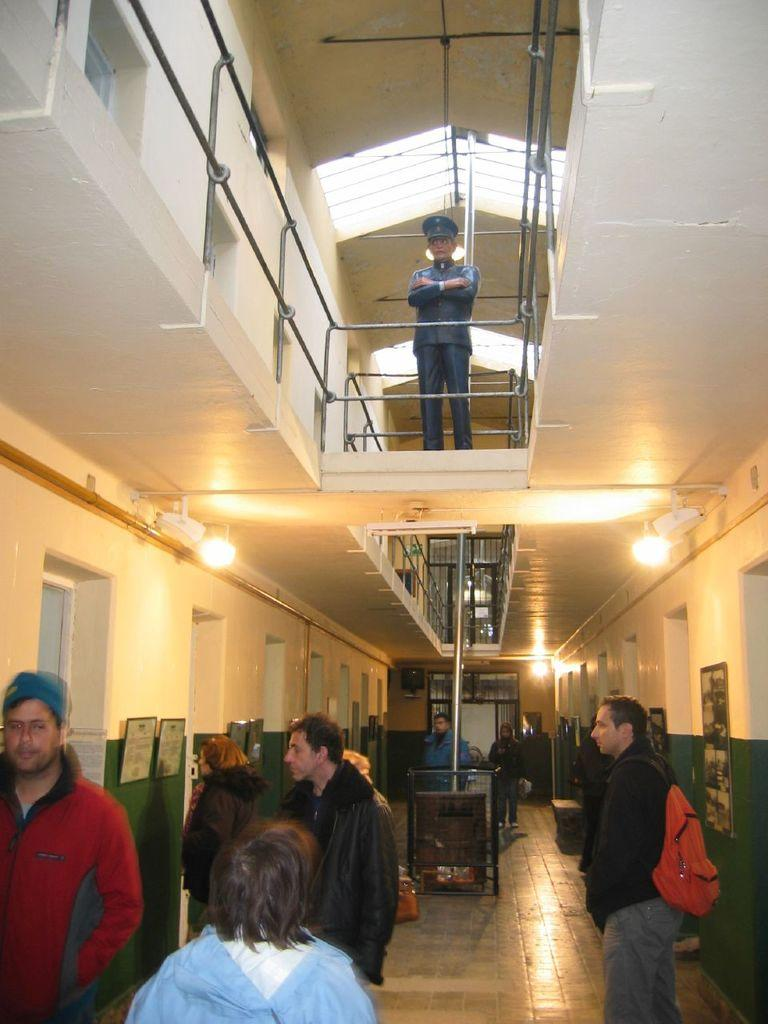What type of structure can be seen in the image? There is a wall in the image. What decorative items are present on the wall? There are photo frames in the image. What type of illumination is visible in the image? There are lights in the image. Are there any people in the image? Yes, there are people present in the image. What type of trousers can be seen in the photo frames? There are no trousers visible in the image, as the focus is on the wall, photo frames, lights, and people. What occasion is being celebrated in the image? There is no indication of a birthday or any other celebration in the image. 